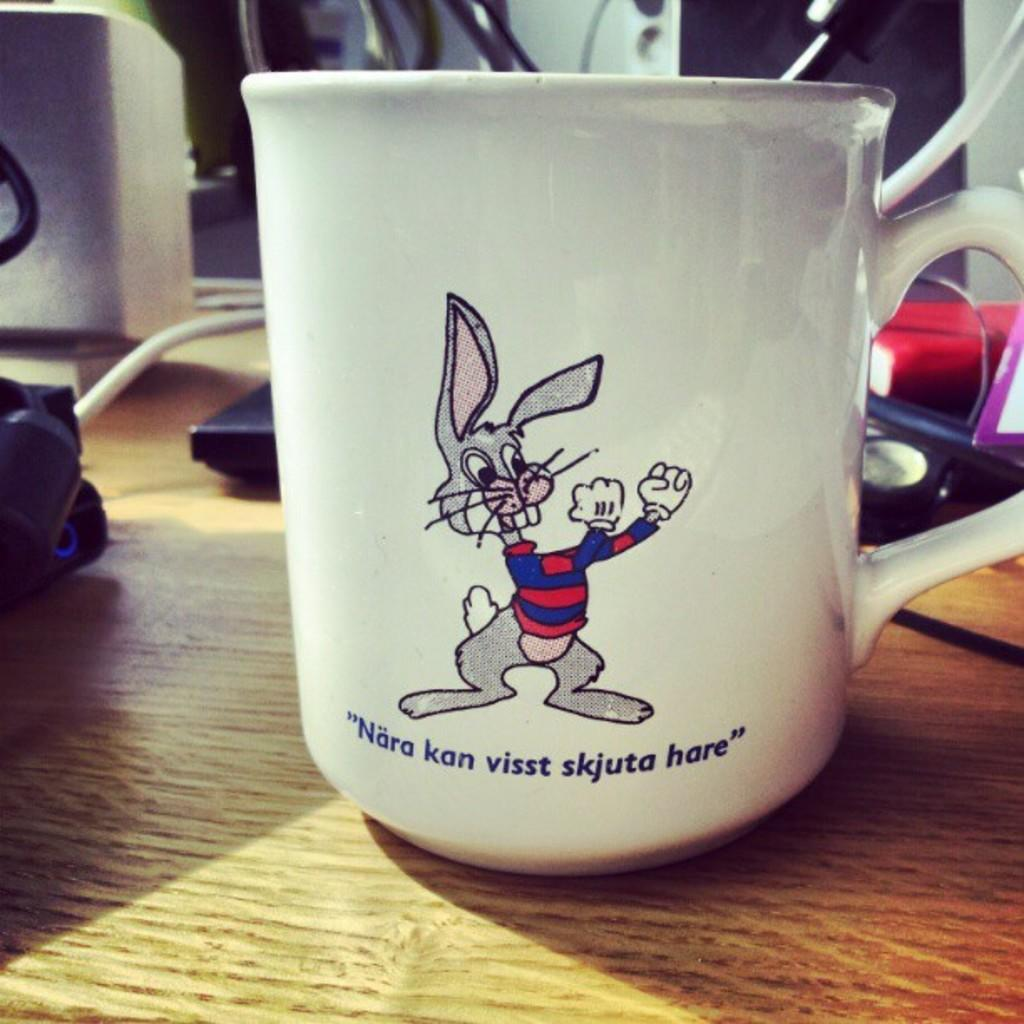Provide a one-sentence caption for the provided image. A bunny on a mug saying Nara kan visst skjuta hare. 